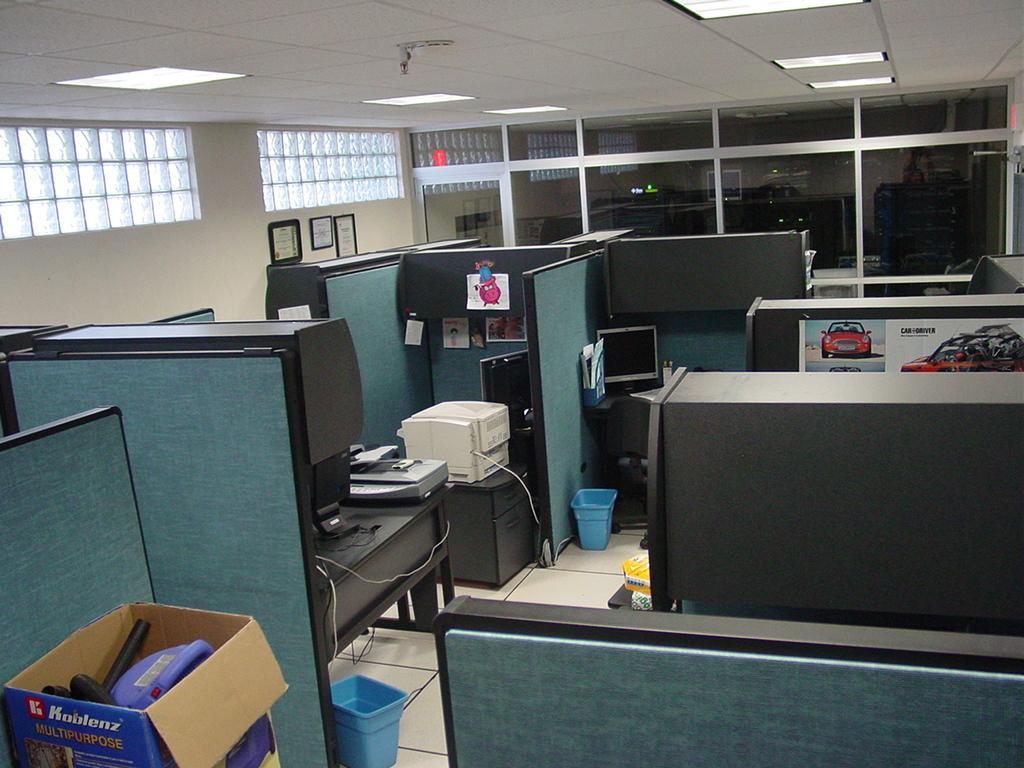In one or two sentences, can you explain what this image depicts? In this image there are monitors, there are objects which are black and blue in colour, there is a printer and there are cabins. On the left side there are frames on the wall. In the background there are windows and at the top there are lights. In the front there is a box and in the box there are objects which are black and purple in colour and there are posters on the partition wall of cabin. 